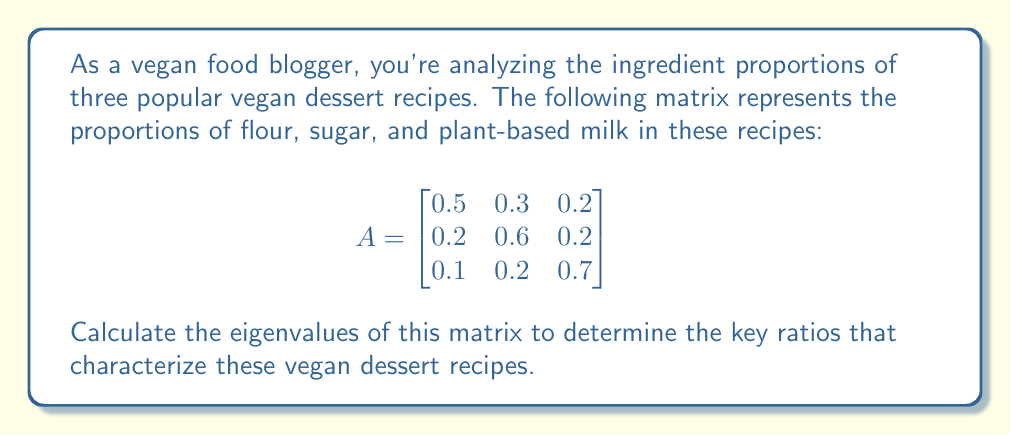Solve this math problem. To find the eigenvalues of matrix A, we need to solve the characteristic equation:

1) First, we set up the equation $det(A - \lambda I) = 0$, where $I$ is the 3x3 identity matrix:

   $$det\begin{pmatrix}
   0.5-\lambda & 0.3 & 0.2 \\
   0.2 & 0.6-\lambda & 0.2 \\
   0.1 & 0.2 & 0.7-\lambda
   \end{pmatrix} = 0$$

2) Expand the determinant:
   $(0.5-\lambda)[(0.6-\lambda)(0.7-\lambda) - 0.04] - 0.3[0.2(0.7-\lambda) - 0.02] + 0.2[0.2(0.2) - 0.1(0.6-\lambda)] = 0$

3) Simplify:
   $(0.5-\lambda)(0.42-1.3\lambda+\lambda^2) - 0.3(0.14-0.2\lambda) + 0.2(0.04-0.06+0.1\lambda) = 0$

4) Expand further:
   $0.21-0.65\lambda+0.5\lambda^2-0.42\lambda+1.3\lambda^2-\lambda^3 - 0.042+0.06\lambda + 0.008-0.012+0.02\lambda = 0$

5) Collect terms:
   $-\lambda^3 + 1.8\lambda^2 - 1.012\lambda + 0.176 = 0$

6) This is a cubic equation. We can solve it using the cubic formula or a numerical method. Using a computer algebra system, we find the roots:

   $\lambda_1 \approx 1$
   $\lambda_2 \approx 0.5$
   $\lambda_3 \approx 0.3$

These are the eigenvalues of the matrix A.
Answer: $\lambda_1 = 1, \lambda_2 = 0.5, \lambda_3 = 0.3$ 